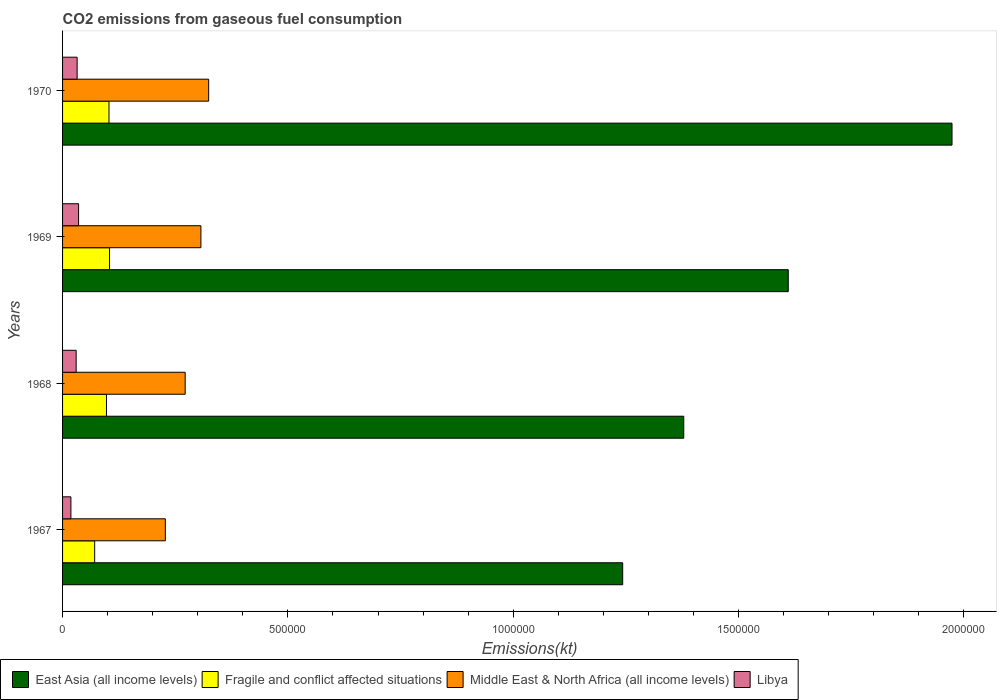How many different coloured bars are there?
Your answer should be very brief. 4. How many groups of bars are there?
Your response must be concise. 4. Are the number of bars on each tick of the Y-axis equal?
Provide a succinct answer. Yes. How many bars are there on the 2nd tick from the top?
Give a very brief answer. 4. How many bars are there on the 1st tick from the bottom?
Your answer should be very brief. 4. What is the label of the 2nd group of bars from the top?
Offer a very short reply. 1969. In how many cases, is the number of bars for a given year not equal to the number of legend labels?
Offer a terse response. 0. What is the amount of CO2 emitted in East Asia (all income levels) in 1967?
Your response must be concise. 1.24e+06. Across all years, what is the maximum amount of CO2 emitted in Libya?
Give a very brief answer. 3.56e+04. Across all years, what is the minimum amount of CO2 emitted in Middle East & North Africa (all income levels)?
Offer a very short reply. 2.28e+05. In which year was the amount of CO2 emitted in East Asia (all income levels) maximum?
Ensure brevity in your answer.  1970. In which year was the amount of CO2 emitted in Libya minimum?
Your answer should be compact. 1967. What is the total amount of CO2 emitted in Fragile and conflict affected situations in the graph?
Ensure brevity in your answer.  3.76e+05. What is the difference between the amount of CO2 emitted in Fragile and conflict affected situations in 1968 and that in 1970?
Provide a succinct answer. -5543.5. What is the difference between the amount of CO2 emitted in Middle East & North Africa (all income levels) in 1967 and the amount of CO2 emitted in East Asia (all income levels) in 1969?
Your answer should be very brief. -1.38e+06. What is the average amount of CO2 emitted in Libya per year?
Make the answer very short. 2.91e+04. In the year 1968, what is the difference between the amount of CO2 emitted in Libya and amount of CO2 emitted in Fragile and conflict affected situations?
Make the answer very short. -6.73e+04. What is the ratio of the amount of CO2 emitted in East Asia (all income levels) in 1968 to that in 1970?
Your answer should be compact. 0.7. Is the difference between the amount of CO2 emitted in Libya in 1968 and 1970 greater than the difference between the amount of CO2 emitted in Fragile and conflict affected situations in 1968 and 1970?
Your response must be concise. Yes. What is the difference between the highest and the second highest amount of CO2 emitted in Fragile and conflict affected situations?
Offer a terse response. 1234.86. What is the difference between the highest and the lowest amount of CO2 emitted in Libya?
Give a very brief answer. 1.70e+04. Is the sum of the amount of CO2 emitted in Middle East & North Africa (all income levels) in 1967 and 1970 greater than the maximum amount of CO2 emitted in Libya across all years?
Your answer should be very brief. Yes. What does the 3rd bar from the top in 1969 represents?
Keep it short and to the point. Fragile and conflict affected situations. What does the 3rd bar from the bottom in 1967 represents?
Offer a very short reply. Middle East & North Africa (all income levels). Is it the case that in every year, the sum of the amount of CO2 emitted in Fragile and conflict affected situations and amount of CO2 emitted in East Asia (all income levels) is greater than the amount of CO2 emitted in Libya?
Provide a succinct answer. Yes. How many bars are there?
Keep it short and to the point. 16. What is the difference between two consecutive major ticks on the X-axis?
Offer a very short reply. 5.00e+05. Are the values on the major ticks of X-axis written in scientific E-notation?
Keep it short and to the point. No. Does the graph contain any zero values?
Ensure brevity in your answer.  No. Does the graph contain grids?
Ensure brevity in your answer.  No. Where does the legend appear in the graph?
Provide a short and direct response. Bottom left. How are the legend labels stacked?
Offer a very short reply. Horizontal. What is the title of the graph?
Ensure brevity in your answer.  CO2 emissions from gaseous fuel consumption. Does "Vietnam" appear as one of the legend labels in the graph?
Your response must be concise. No. What is the label or title of the X-axis?
Provide a succinct answer. Emissions(kt). What is the label or title of the Y-axis?
Provide a short and direct response. Years. What is the Emissions(kt) in East Asia (all income levels) in 1967?
Your answer should be compact. 1.24e+06. What is the Emissions(kt) in Fragile and conflict affected situations in 1967?
Offer a terse response. 7.12e+04. What is the Emissions(kt) of Middle East & North Africa (all income levels) in 1967?
Offer a terse response. 2.28e+05. What is the Emissions(kt) in Libya in 1967?
Offer a terse response. 1.85e+04. What is the Emissions(kt) of East Asia (all income levels) in 1968?
Your answer should be compact. 1.38e+06. What is the Emissions(kt) of Fragile and conflict affected situations in 1968?
Offer a very short reply. 9.75e+04. What is the Emissions(kt) of Middle East & North Africa (all income levels) in 1968?
Your answer should be compact. 2.72e+05. What is the Emissions(kt) of Libya in 1968?
Ensure brevity in your answer.  3.01e+04. What is the Emissions(kt) of East Asia (all income levels) in 1969?
Keep it short and to the point. 1.61e+06. What is the Emissions(kt) in Fragile and conflict affected situations in 1969?
Offer a very short reply. 1.04e+05. What is the Emissions(kt) in Middle East & North Africa (all income levels) in 1969?
Your answer should be very brief. 3.07e+05. What is the Emissions(kt) of Libya in 1969?
Your answer should be very brief. 3.56e+04. What is the Emissions(kt) of East Asia (all income levels) in 1970?
Offer a terse response. 1.97e+06. What is the Emissions(kt) in Fragile and conflict affected situations in 1970?
Provide a short and direct response. 1.03e+05. What is the Emissions(kt) in Middle East & North Africa (all income levels) in 1970?
Your answer should be very brief. 3.24e+05. What is the Emissions(kt) in Libya in 1970?
Provide a succinct answer. 3.23e+04. Across all years, what is the maximum Emissions(kt) of East Asia (all income levels)?
Your response must be concise. 1.97e+06. Across all years, what is the maximum Emissions(kt) in Fragile and conflict affected situations?
Offer a very short reply. 1.04e+05. Across all years, what is the maximum Emissions(kt) in Middle East & North Africa (all income levels)?
Give a very brief answer. 3.24e+05. Across all years, what is the maximum Emissions(kt) of Libya?
Make the answer very short. 3.56e+04. Across all years, what is the minimum Emissions(kt) in East Asia (all income levels)?
Your answer should be compact. 1.24e+06. Across all years, what is the minimum Emissions(kt) in Fragile and conflict affected situations?
Make the answer very short. 7.12e+04. Across all years, what is the minimum Emissions(kt) in Middle East & North Africa (all income levels)?
Your answer should be very brief. 2.28e+05. Across all years, what is the minimum Emissions(kt) of Libya?
Make the answer very short. 1.85e+04. What is the total Emissions(kt) of East Asia (all income levels) in the graph?
Keep it short and to the point. 6.21e+06. What is the total Emissions(kt) of Fragile and conflict affected situations in the graph?
Your answer should be compact. 3.76e+05. What is the total Emissions(kt) in Middle East & North Africa (all income levels) in the graph?
Your answer should be compact. 1.13e+06. What is the total Emissions(kt) of Libya in the graph?
Offer a terse response. 1.17e+05. What is the difference between the Emissions(kt) in East Asia (all income levels) in 1967 and that in 1968?
Provide a short and direct response. -1.36e+05. What is the difference between the Emissions(kt) in Fragile and conflict affected situations in 1967 and that in 1968?
Provide a short and direct response. -2.62e+04. What is the difference between the Emissions(kt) of Middle East & North Africa (all income levels) in 1967 and that in 1968?
Provide a succinct answer. -4.40e+04. What is the difference between the Emissions(kt) of Libya in 1967 and that in 1968?
Offer a terse response. -1.16e+04. What is the difference between the Emissions(kt) in East Asia (all income levels) in 1967 and that in 1969?
Provide a succinct answer. -3.67e+05. What is the difference between the Emissions(kt) in Fragile and conflict affected situations in 1967 and that in 1969?
Your answer should be very brief. -3.30e+04. What is the difference between the Emissions(kt) of Middle East & North Africa (all income levels) in 1967 and that in 1969?
Offer a terse response. -7.89e+04. What is the difference between the Emissions(kt) in Libya in 1967 and that in 1969?
Keep it short and to the point. -1.70e+04. What is the difference between the Emissions(kt) in East Asia (all income levels) in 1967 and that in 1970?
Ensure brevity in your answer.  -7.31e+05. What is the difference between the Emissions(kt) in Fragile and conflict affected situations in 1967 and that in 1970?
Your answer should be compact. -3.18e+04. What is the difference between the Emissions(kt) of Middle East & North Africa (all income levels) in 1967 and that in 1970?
Give a very brief answer. -9.62e+04. What is the difference between the Emissions(kt) in Libya in 1967 and that in 1970?
Provide a succinct answer. -1.38e+04. What is the difference between the Emissions(kt) of East Asia (all income levels) in 1968 and that in 1969?
Your response must be concise. -2.32e+05. What is the difference between the Emissions(kt) of Fragile and conflict affected situations in 1968 and that in 1969?
Keep it short and to the point. -6778.37. What is the difference between the Emissions(kt) of Middle East & North Africa (all income levels) in 1968 and that in 1969?
Keep it short and to the point. -3.49e+04. What is the difference between the Emissions(kt) of Libya in 1968 and that in 1969?
Ensure brevity in your answer.  -5412.49. What is the difference between the Emissions(kt) in East Asia (all income levels) in 1968 and that in 1970?
Offer a very short reply. -5.95e+05. What is the difference between the Emissions(kt) in Fragile and conflict affected situations in 1968 and that in 1970?
Keep it short and to the point. -5543.5. What is the difference between the Emissions(kt) in Middle East & North Africa (all income levels) in 1968 and that in 1970?
Give a very brief answer. -5.21e+04. What is the difference between the Emissions(kt) in Libya in 1968 and that in 1970?
Your answer should be very brief. -2192.87. What is the difference between the Emissions(kt) of East Asia (all income levels) in 1969 and that in 1970?
Your answer should be compact. -3.63e+05. What is the difference between the Emissions(kt) of Fragile and conflict affected situations in 1969 and that in 1970?
Offer a terse response. 1234.86. What is the difference between the Emissions(kt) of Middle East & North Africa (all income levels) in 1969 and that in 1970?
Make the answer very short. -1.72e+04. What is the difference between the Emissions(kt) in Libya in 1969 and that in 1970?
Provide a succinct answer. 3219.63. What is the difference between the Emissions(kt) in East Asia (all income levels) in 1967 and the Emissions(kt) in Fragile and conflict affected situations in 1968?
Give a very brief answer. 1.15e+06. What is the difference between the Emissions(kt) of East Asia (all income levels) in 1967 and the Emissions(kt) of Middle East & North Africa (all income levels) in 1968?
Keep it short and to the point. 9.71e+05. What is the difference between the Emissions(kt) of East Asia (all income levels) in 1967 and the Emissions(kt) of Libya in 1968?
Ensure brevity in your answer.  1.21e+06. What is the difference between the Emissions(kt) in Fragile and conflict affected situations in 1967 and the Emissions(kt) in Middle East & North Africa (all income levels) in 1968?
Your response must be concise. -2.01e+05. What is the difference between the Emissions(kt) of Fragile and conflict affected situations in 1967 and the Emissions(kt) of Libya in 1968?
Make the answer very short. 4.11e+04. What is the difference between the Emissions(kt) in Middle East & North Africa (all income levels) in 1967 and the Emissions(kt) in Libya in 1968?
Provide a short and direct response. 1.98e+05. What is the difference between the Emissions(kt) of East Asia (all income levels) in 1967 and the Emissions(kt) of Fragile and conflict affected situations in 1969?
Your answer should be compact. 1.14e+06. What is the difference between the Emissions(kt) in East Asia (all income levels) in 1967 and the Emissions(kt) in Middle East & North Africa (all income levels) in 1969?
Keep it short and to the point. 9.36e+05. What is the difference between the Emissions(kt) in East Asia (all income levels) in 1967 and the Emissions(kt) in Libya in 1969?
Offer a very short reply. 1.21e+06. What is the difference between the Emissions(kt) in Fragile and conflict affected situations in 1967 and the Emissions(kt) in Middle East & North Africa (all income levels) in 1969?
Your answer should be very brief. -2.36e+05. What is the difference between the Emissions(kt) in Fragile and conflict affected situations in 1967 and the Emissions(kt) in Libya in 1969?
Make the answer very short. 3.57e+04. What is the difference between the Emissions(kt) of Middle East & North Africa (all income levels) in 1967 and the Emissions(kt) of Libya in 1969?
Offer a terse response. 1.92e+05. What is the difference between the Emissions(kt) in East Asia (all income levels) in 1967 and the Emissions(kt) in Fragile and conflict affected situations in 1970?
Provide a short and direct response. 1.14e+06. What is the difference between the Emissions(kt) in East Asia (all income levels) in 1967 and the Emissions(kt) in Middle East & North Africa (all income levels) in 1970?
Your response must be concise. 9.19e+05. What is the difference between the Emissions(kt) of East Asia (all income levels) in 1967 and the Emissions(kt) of Libya in 1970?
Offer a terse response. 1.21e+06. What is the difference between the Emissions(kt) in Fragile and conflict affected situations in 1967 and the Emissions(kt) in Middle East & North Africa (all income levels) in 1970?
Make the answer very short. -2.53e+05. What is the difference between the Emissions(kt) of Fragile and conflict affected situations in 1967 and the Emissions(kt) of Libya in 1970?
Your response must be concise. 3.89e+04. What is the difference between the Emissions(kt) of Middle East & North Africa (all income levels) in 1967 and the Emissions(kt) of Libya in 1970?
Make the answer very short. 1.96e+05. What is the difference between the Emissions(kt) of East Asia (all income levels) in 1968 and the Emissions(kt) of Fragile and conflict affected situations in 1969?
Your response must be concise. 1.27e+06. What is the difference between the Emissions(kt) in East Asia (all income levels) in 1968 and the Emissions(kt) in Middle East & North Africa (all income levels) in 1969?
Give a very brief answer. 1.07e+06. What is the difference between the Emissions(kt) in East Asia (all income levels) in 1968 and the Emissions(kt) in Libya in 1969?
Provide a succinct answer. 1.34e+06. What is the difference between the Emissions(kt) of Fragile and conflict affected situations in 1968 and the Emissions(kt) of Middle East & North Africa (all income levels) in 1969?
Give a very brief answer. -2.10e+05. What is the difference between the Emissions(kt) in Fragile and conflict affected situations in 1968 and the Emissions(kt) in Libya in 1969?
Offer a terse response. 6.19e+04. What is the difference between the Emissions(kt) in Middle East & North Africa (all income levels) in 1968 and the Emissions(kt) in Libya in 1969?
Offer a terse response. 2.37e+05. What is the difference between the Emissions(kt) in East Asia (all income levels) in 1968 and the Emissions(kt) in Fragile and conflict affected situations in 1970?
Make the answer very short. 1.28e+06. What is the difference between the Emissions(kt) of East Asia (all income levels) in 1968 and the Emissions(kt) of Middle East & North Africa (all income levels) in 1970?
Provide a succinct answer. 1.05e+06. What is the difference between the Emissions(kt) in East Asia (all income levels) in 1968 and the Emissions(kt) in Libya in 1970?
Keep it short and to the point. 1.35e+06. What is the difference between the Emissions(kt) in Fragile and conflict affected situations in 1968 and the Emissions(kt) in Middle East & North Africa (all income levels) in 1970?
Keep it short and to the point. -2.27e+05. What is the difference between the Emissions(kt) of Fragile and conflict affected situations in 1968 and the Emissions(kt) of Libya in 1970?
Ensure brevity in your answer.  6.51e+04. What is the difference between the Emissions(kt) in Middle East & North Africa (all income levels) in 1968 and the Emissions(kt) in Libya in 1970?
Give a very brief answer. 2.40e+05. What is the difference between the Emissions(kt) in East Asia (all income levels) in 1969 and the Emissions(kt) in Fragile and conflict affected situations in 1970?
Your response must be concise. 1.51e+06. What is the difference between the Emissions(kt) of East Asia (all income levels) in 1969 and the Emissions(kt) of Middle East & North Africa (all income levels) in 1970?
Offer a very short reply. 1.29e+06. What is the difference between the Emissions(kt) in East Asia (all income levels) in 1969 and the Emissions(kt) in Libya in 1970?
Your answer should be very brief. 1.58e+06. What is the difference between the Emissions(kt) of Fragile and conflict affected situations in 1969 and the Emissions(kt) of Middle East & North Africa (all income levels) in 1970?
Provide a short and direct response. -2.20e+05. What is the difference between the Emissions(kt) in Fragile and conflict affected situations in 1969 and the Emissions(kt) in Libya in 1970?
Offer a terse response. 7.19e+04. What is the difference between the Emissions(kt) in Middle East & North Africa (all income levels) in 1969 and the Emissions(kt) in Libya in 1970?
Provide a succinct answer. 2.75e+05. What is the average Emissions(kt) in East Asia (all income levels) per year?
Make the answer very short. 1.55e+06. What is the average Emissions(kt) of Fragile and conflict affected situations per year?
Your answer should be compact. 9.40e+04. What is the average Emissions(kt) in Middle East & North Africa (all income levels) per year?
Offer a terse response. 2.83e+05. What is the average Emissions(kt) of Libya per year?
Ensure brevity in your answer.  2.91e+04. In the year 1967, what is the difference between the Emissions(kt) in East Asia (all income levels) and Emissions(kt) in Fragile and conflict affected situations?
Keep it short and to the point. 1.17e+06. In the year 1967, what is the difference between the Emissions(kt) in East Asia (all income levels) and Emissions(kt) in Middle East & North Africa (all income levels)?
Ensure brevity in your answer.  1.01e+06. In the year 1967, what is the difference between the Emissions(kt) in East Asia (all income levels) and Emissions(kt) in Libya?
Offer a very short reply. 1.22e+06. In the year 1967, what is the difference between the Emissions(kt) of Fragile and conflict affected situations and Emissions(kt) of Middle East & North Africa (all income levels)?
Provide a succinct answer. -1.57e+05. In the year 1967, what is the difference between the Emissions(kt) in Fragile and conflict affected situations and Emissions(kt) in Libya?
Ensure brevity in your answer.  5.27e+04. In the year 1967, what is the difference between the Emissions(kt) in Middle East & North Africa (all income levels) and Emissions(kt) in Libya?
Provide a succinct answer. 2.10e+05. In the year 1968, what is the difference between the Emissions(kt) in East Asia (all income levels) and Emissions(kt) in Fragile and conflict affected situations?
Make the answer very short. 1.28e+06. In the year 1968, what is the difference between the Emissions(kt) in East Asia (all income levels) and Emissions(kt) in Middle East & North Africa (all income levels)?
Provide a short and direct response. 1.11e+06. In the year 1968, what is the difference between the Emissions(kt) of East Asia (all income levels) and Emissions(kt) of Libya?
Make the answer very short. 1.35e+06. In the year 1968, what is the difference between the Emissions(kt) of Fragile and conflict affected situations and Emissions(kt) of Middle East & North Africa (all income levels)?
Provide a short and direct response. -1.75e+05. In the year 1968, what is the difference between the Emissions(kt) in Fragile and conflict affected situations and Emissions(kt) in Libya?
Provide a succinct answer. 6.73e+04. In the year 1968, what is the difference between the Emissions(kt) in Middle East & North Africa (all income levels) and Emissions(kt) in Libya?
Your answer should be very brief. 2.42e+05. In the year 1969, what is the difference between the Emissions(kt) of East Asia (all income levels) and Emissions(kt) of Fragile and conflict affected situations?
Your answer should be compact. 1.51e+06. In the year 1969, what is the difference between the Emissions(kt) in East Asia (all income levels) and Emissions(kt) in Middle East & North Africa (all income levels)?
Keep it short and to the point. 1.30e+06. In the year 1969, what is the difference between the Emissions(kt) in East Asia (all income levels) and Emissions(kt) in Libya?
Provide a succinct answer. 1.57e+06. In the year 1969, what is the difference between the Emissions(kt) in Fragile and conflict affected situations and Emissions(kt) in Middle East & North Africa (all income levels)?
Your answer should be very brief. -2.03e+05. In the year 1969, what is the difference between the Emissions(kt) of Fragile and conflict affected situations and Emissions(kt) of Libya?
Provide a short and direct response. 6.87e+04. In the year 1969, what is the difference between the Emissions(kt) of Middle East & North Africa (all income levels) and Emissions(kt) of Libya?
Ensure brevity in your answer.  2.71e+05. In the year 1970, what is the difference between the Emissions(kt) in East Asia (all income levels) and Emissions(kt) in Fragile and conflict affected situations?
Your answer should be very brief. 1.87e+06. In the year 1970, what is the difference between the Emissions(kt) in East Asia (all income levels) and Emissions(kt) in Middle East & North Africa (all income levels)?
Offer a terse response. 1.65e+06. In the year 1970, what is the difference between the Emissions(kt) of East Asia (all income levels) and Emissions(kt) of Libya?
Your answer should be very brief. 1.94e+06. In the year 1970, what is the difference between the Emissions(kt) of Fragile and conflict affected situations and Emissions(kt) of Middle East & North Africa (all income levels)?
Offer a terse response. -2.21e+05. In the year 1970, what is the difference between the Emissions(kt) of Fragile and conflict affected situations and Emissions(kt) of Libya?
Your answer should be very brief. 7.07e+04. In the year 1970, what is the difference between the Emissions(kt) in Middle East & North Africa (all income levels) and Emissions(kt) in Libya?
Your answer should be compact. 2.92e+05. What is the ratio of the Emissions(kt) of East Asia (all income levels) in 1967 to that in 1968?
Give a very brief answer. 0.9. What is the ratio of the Emissions(kt) in Fragile and conflict affected situations in 1967 to that in 1968?
Provide a short and direct response. 0.73. What is the ratio of the Emissions(kt) of Middle East & North Africa (all income levels) in 1967 to that in 1968?
Provide a succinct answer. 0.84. What is the ratio of the Emissions(kt) in Libya in 1967 to that in 1968?
Keep it short and to the point. 0.61. What is the ratio of the Emissions(kt) in East Asia (all income levels) in 1967 to that in 1969?
Provide a short and direct response. 0.77. What is the ratio of the Emissions(kt) in Fragile and conflict affected situations in 1967 to that in 1969?
Provide a short and direct response. 0.68. What is the ratio of the Emissions(kt) in Middle East & North Africa (all income levels) in 1967 to that in 1969?
Offer a very short reply. 0.74. What is the ratio of the Emissions(kt) in Libya in 1967 to that in 1969?
Give a very brief answer. 0.52. What is the ratio of the Emissions(kt) in East Asia (all income levels) in 1967 to that in 1970?
Provide a short and direct response. 0.63. What is the ratio of the Emissions(kt) of Fragile and conflict affected situations in 1967 to that in 1970?
Your answer should be compact. 0.69. What is the ratio of the Emissions(kt) of Middle East & North Africa (all income levels) in 1967 to that in 1970?
Provide a succinct answer. 0.7. What is the ratio of the Emissions(kt) in Libya in 1967 to that in 1970?
Provide a short and direct response. 0.57. What is the ratio of the Emissions(kt) in East Asia (all income levels) in 1968 to that in 1969?
Keep it short and to the point. 0.86. What is the ratio of the Emissions(kt) in Fragile and conflict affected situations in 1968 to that in 1969?
Give a very brief answer. 0.94. What is the ratio of the Emissions(kt) in Middle East & North Africa (all income levels) in 1968 to that in 1969?
Offer a very short reply. 0.89. What is the ratio of the Emissions(kt) in Libya in 1968 to that in 1969?
Make the answer very short. 0.85. What is the ratio of the Emissions(kt) of East Asia (all income levels) in 1968 to that in 1970?
Offer a terse response. 0.7. What is the ratio of the Emissions(kt) in Fragile and conflict affected situations in 1968 to that in 1970?
Offer a very short reply. 0.95. What is the ratio of the Emissions(kt) in Middle East & North Africa (all income levels) in 1968 to that in 1970?
Offer a terse response. 0.84. What is the ratio of the Emissions(kt) in Libya in 1968 to that in 1970?
Give a very brief answer. 0.93. What is the ratio of the Emissions(kt) in East Asia (all income levels) in 1969 to that in 1970?
Offer a terse response. 0.82. What is the ratio of the Emissions(kt) of Middle East & North Africa (all income levels) in 1969 to that in 1970?
Ensure brevity in your answer.  0.95. What is the ratio of the Emissions(kt) of Libya in 1969 to that in 1970?
Provide a succinct answer. 1.1. What is the difference between the highest and the second highest Emissions(kt) of East Asia (all income levels)?
Provide a short and direct response. 3.63e+05. What is the difference between the highest and the second highest Emissions(kt) of Fragile and conflict affected situations?
Keep it short and to the point. 1234.86. What is the difference between the highest and the second highest Emissions(kt) in Middle East & North Africa (all income levels)?
Give a very brief answer. 1.72e+04. What is the difference between the highest and the second highest Emissions(kt) of Libya?
Your answer should be compact. 3219.63. What is the difference between the highest and the lowest Emissions(kt) in East Asia (all income levels)?
Provide a short and direct response. 7.31e+05. What is the difference between the highest and the lowest Emissions(kt) in Fragile and conflict affected situations?
Provide a succinct answer. 3.30e+04. What is the difference between the highest and the lowest Emissions(kt) of Middle East & North Africa (all income levels)?
Offer a terse response. 9.62e+04. What is the difference between the highest and the lowest Emissions(kt) of Libya?
Your answer should be compact. 1.70e+04. 